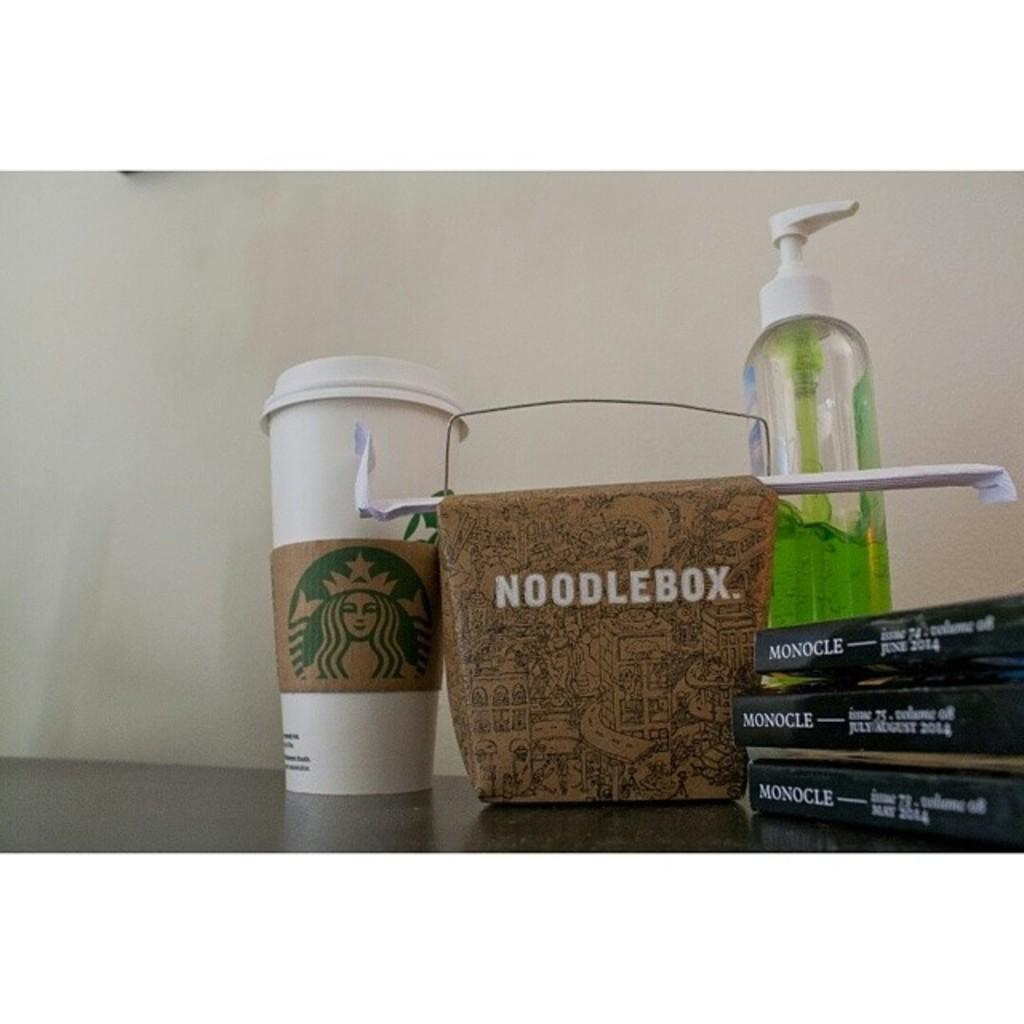What type of container is visible in the image? There is a coffee mug in the image. What else can be seen in the image besides the coffee mug? There is a noodle box and a hand wash bottle in the image. How many books are present in the image? There are three books in the image. What type of butter is being used in the hospital in the image? There is no butter or hospital present in the image. 